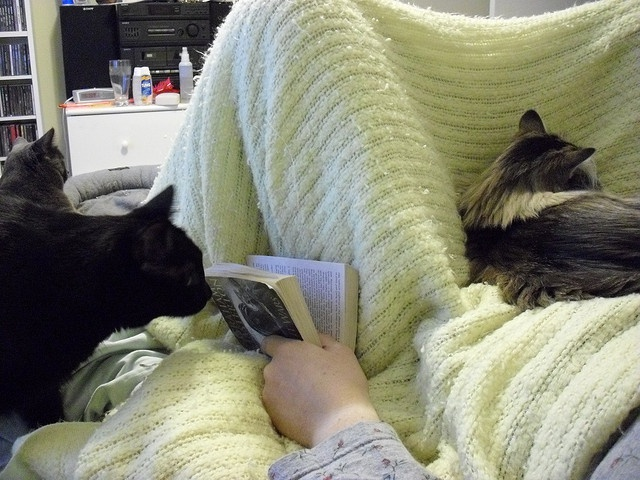Describe the objects in this image and their specific colors. I can see bed in black, darkgray, beige, olive, and gray tones, cat in black, gray, darkgray, and lightgray tones, cat in black, gray, and darkgreen tones, people in black, darkgray, gray, and lightgray tones, and book in black, gray, and darkgray tones in this image. 